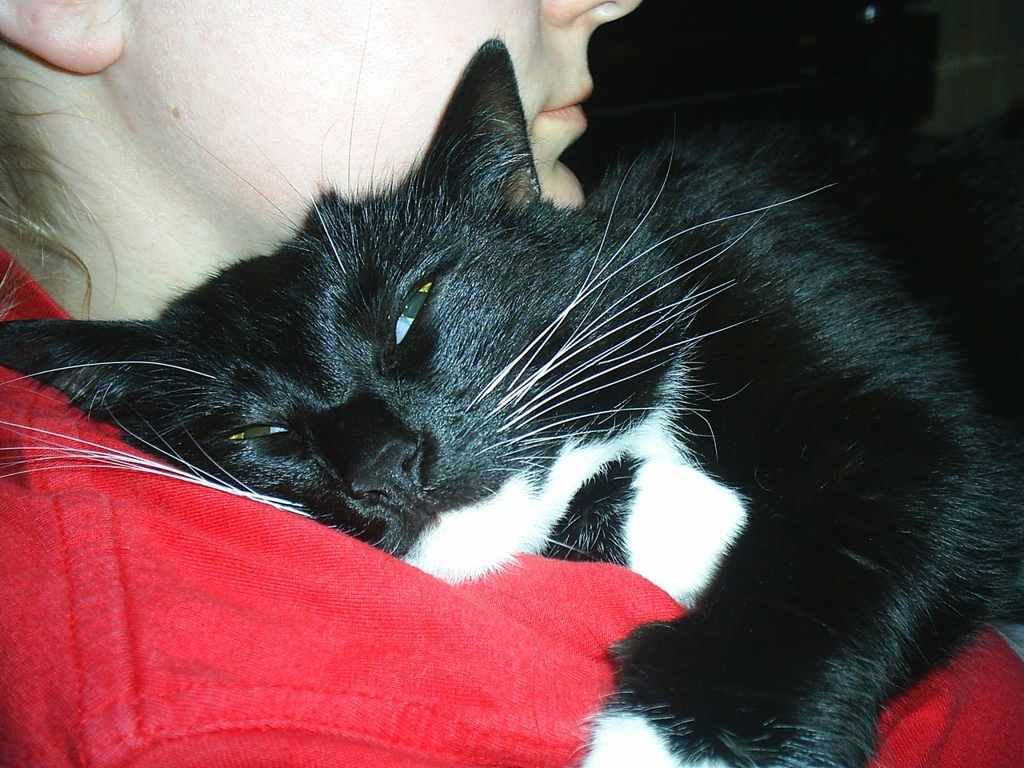Is the image clear? Yes, the image is clear with good focus, allowing us to see the details like the cat's fur texture and the color contrast between the cat and the person's red shirt. The lighting is adequate, and there's no significant blur that would prevent us from understanding what's depicted. 